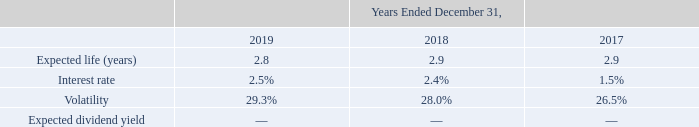Total Shareholder Return Awards
During the years ended December 31, 2019, 2018, and 2017, pursuant to the 2016 Incentive Plan, the Company granted total shareholder return awards (“TSRs”). TSRs are performance shares that are earned, if at all, based upon the Company’s total shareholder return as compared to a group of peer companies over a three-year performance period. The award payout can range from 0% to 200%. To determine the grant date fair value of the TSRs, a Monte Carlo simulation model is used. The Company recognizes compensation expense for the TSRs over a three-year performance period based on the grant date fair value.
The grant date fair value of the TSRs was estimated using the following weighted-average assumptions:
What are TSRs? Performance shares that are earned, if at all, based upon the company’s total shareholder return as compared to a group of peer companies over a three-year performance period. What was the interest rate in 2017? 1.5%. What was the volatility in 2018? 28.0%. What was the change in interest rate between 2018 and 2019?
Answer scale should be: percent. 2.5%-2.4%
Answer: 0.1. What was the change in Volatility between 2017 and 2018?
Answer scale should be: percent. 28.0%-26.5%
Answer: 1.5. What was the percentage change in expected life (years) between 2018 and 2019?
Answer scale should be: percent. (2.8-2.9)/2.9
Answer: -3.45. 